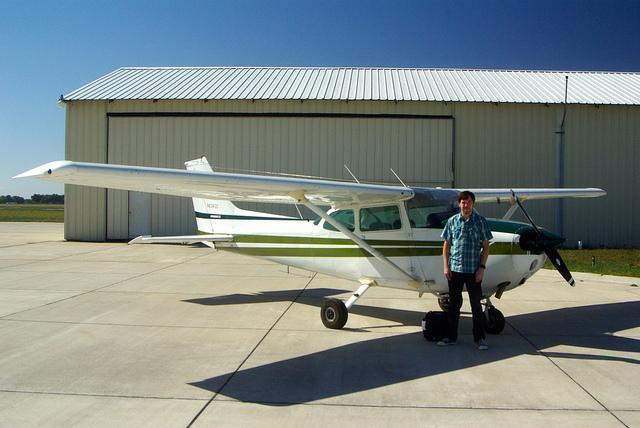Who is this person most likely to be?
Select the accurate response from the four choices given to answer the question.
Options: Burglar, friend, pilot, buyer. Pilot. 